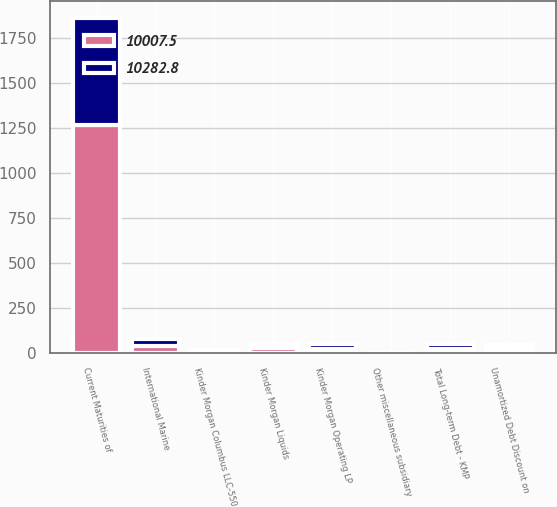Convert chart. <chart><loc_0><loc_0><loc_500><loc_500><stacked_bar_chart><ecel><fcel>Kinder Morgan Liquids<fcel>Kinder Morgan Columbus LLC-550<fcel>Kinder Morgan Operating LP<fcel>International Marine<fcel>Other miscellaneous subsidiary<fcel>Unamortized Debt Discount on<fcel>Current Maturities of<fcel>Total Long-term Debt - KMP<nl><fcel>10007.5<fcel>25<fcel>8.2<fcel>23.7<fcel>40<fcel>1.3<fcel>20.3<fcel>1263.3<fcel>23.7<nl><fcel>10282.8<fcel>25<fcel>8.2<fcel>23.7<fcel>40<fcel>1.3<fcel>21.2<fcel>596.6<fcel>23.7<nl></chart> 